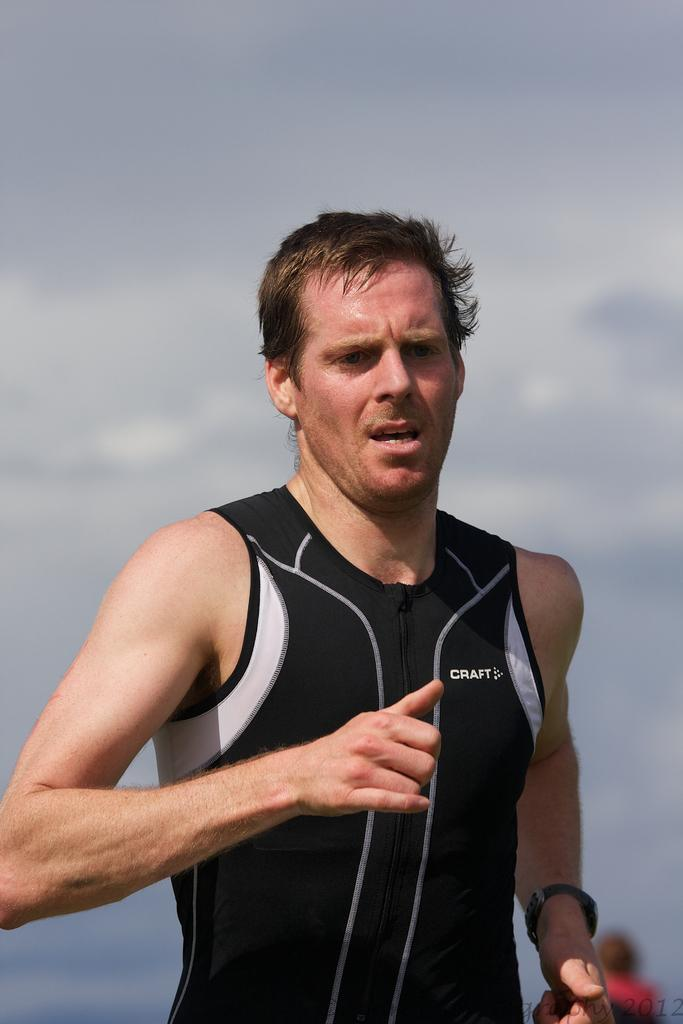<image>
Give a short and clear explanation of the subsequent image. The runner looks tired in his black Craft tank top. 